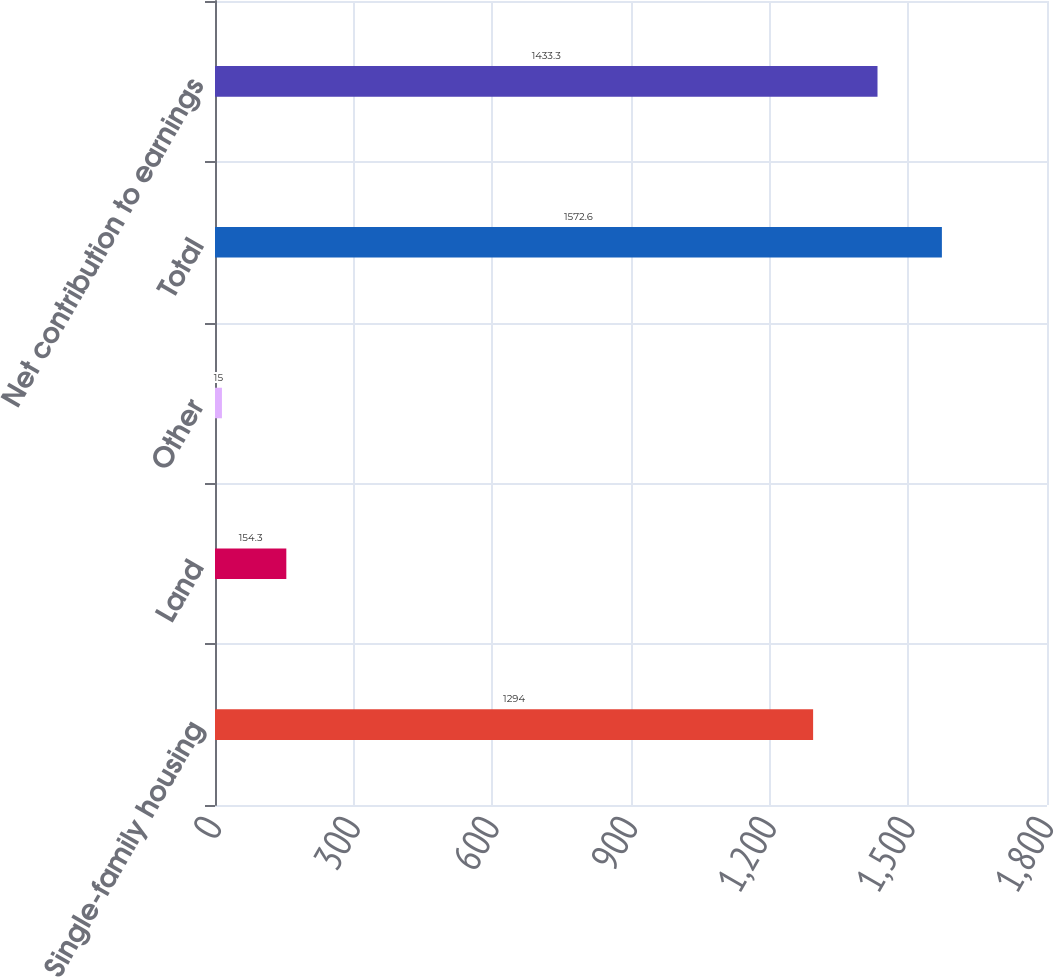Convert chart. <chart><loc_0><loc_0><loc_500><loc_500><bar_chart><fcel>Single-family housing<fcel>Land<fcel>Other<fcel>Total<fcel>Net contribution to earnings<nl><fcel>1294<fcel>154.3<fcel>15<fcel>1572.6<fcel>1433.3<nl></chart> 